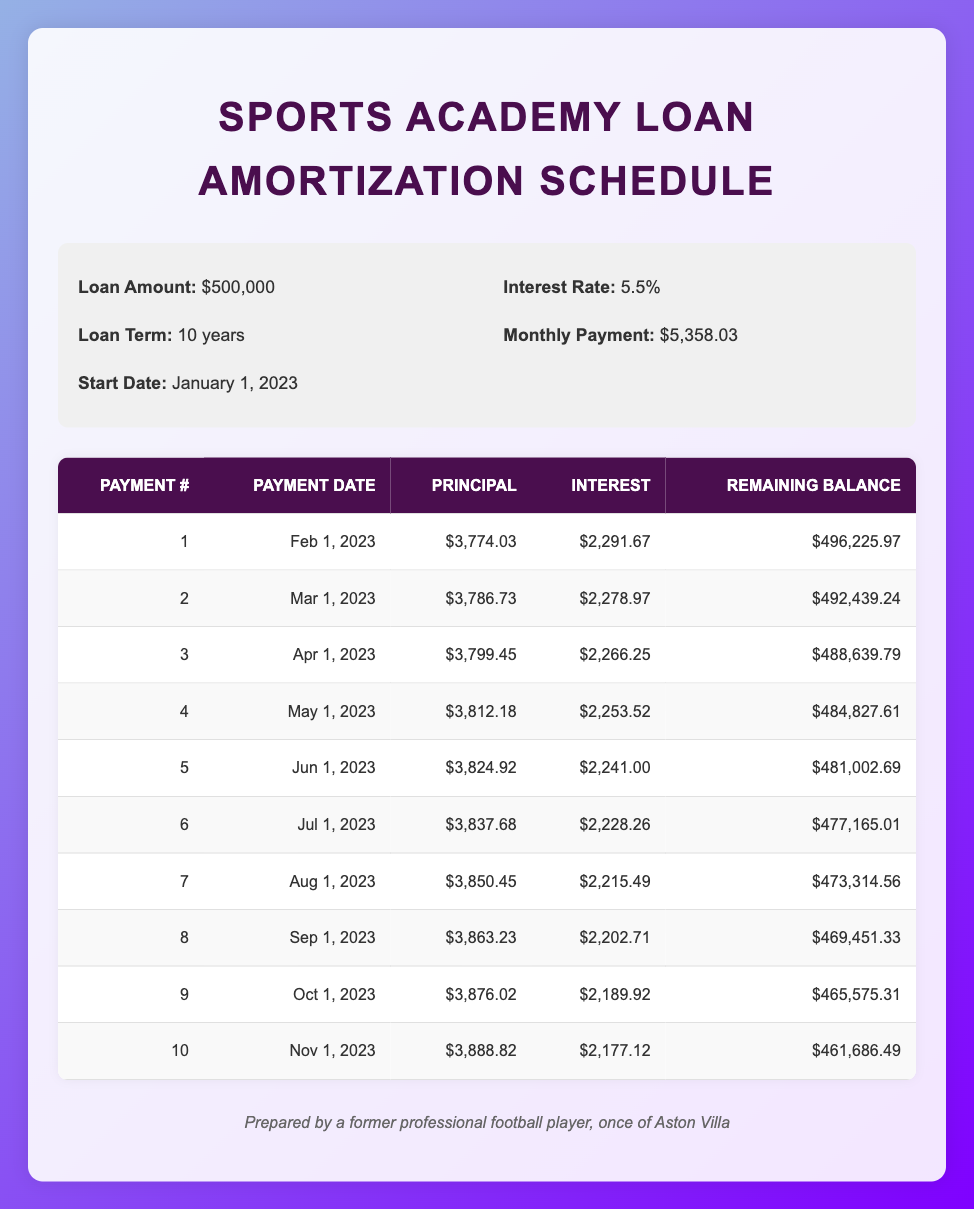What is the loan amount for the sports academy? The loan amount is specified in the loan details section of the table, which states that the loan amount is $500,000.
Answer: $500,000 What will be the monthly payment amount? The monthly payment amount is also provided in the loan details section, where it indicates that the monthly payment is $5,358.03.
Answer: $5,358.03 How much principal is paid in the first payment? The principal payment for the first payment is listed in the amortization schedule under the principal payment column for payment number 1, which shows $3,774.03.
Answer: $3,774.03 Is the interest payment for the second payment greater than the interest payment for the first payment? The interest payment for the second payment is $2,278.97, and for the first payment, it is $2,291.67. Since $2,278.97 is less than $2,291.67, the statement is false.
Answer: No What is the total principal paid after the first three payments? To find the total principal paid after the first three payments, add the principal payments for the first three payments: $3,774.03 + $3,786.73 + $3,799.45 = $11,360.21.
Answer: $11,360.21 What is the remaining balance after the eighth payment? The remaining balance after the eighth payment is listed in the amortization schedule for payment number 8, which shows a remaining balance of $469,451.33.
Answer: $469,451.33 Which payment has the highest principal payment among the first ten? By examining the principal payments for all ten payments, the highest principal payment can be found to be from the tenth payment, which is $3,888.82.
Answer: $3,888.82 What is the average interest payment for the first ten payments? To calculate the average interest payment, we sum the interest payments for the first ten payments and divide by 10. The total interest is $2,291.67 + $2,278.97 + $2,266.25 + $2,253.52 + $2,241.00 + $2,228.26 + $2,215.49 + $2,202.71 + $2,189.92 + $2,177.12 = $22,771.88. The average is $22,771.88 / 10 = $2,277.19.
Answer: $2,277.19 Is the remaining balance after the tenth payment less than $462,000? After the tenth payment, the remaining balance is $461,686.49, which is indeed less than $462,000, thus the statement is true.
Answer: Yes 